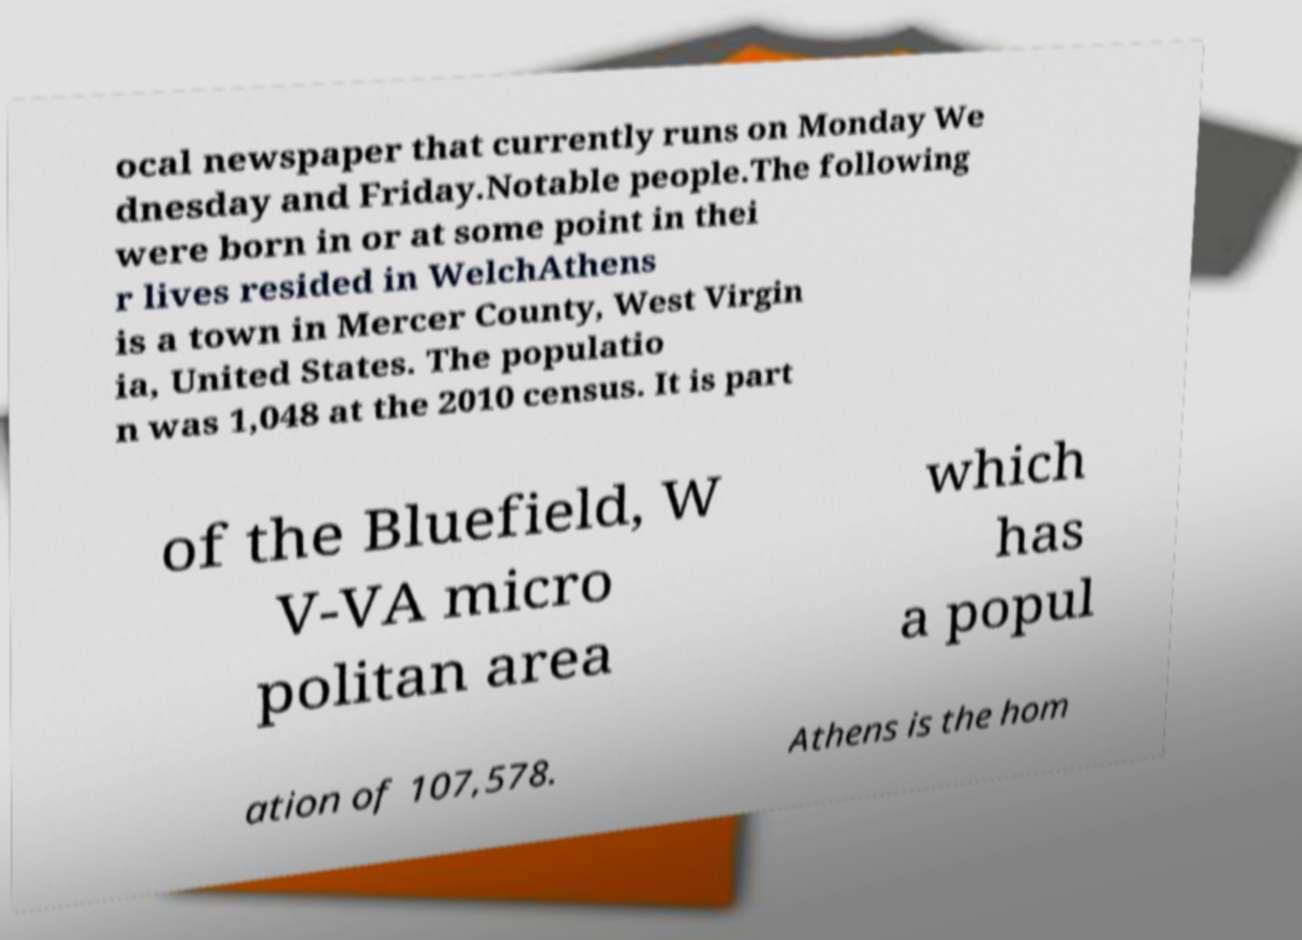Can you read and provide the text displayed in the image?This photo seems to have some interesting text. Can you extract and type it out for me? ocal newspaper that currently runs on Monday We dnesday and Friday.Notable people.The following were born in or at some point in thei r lives resided in WelchAthens is a town in Mercer County, West Virgin ia, United States. The populatio n was 1,048 at the 2010 census. It is part of the Bluefield, W V-VA micro politan area which has a popul ation of 107,578. Athens is the hom 